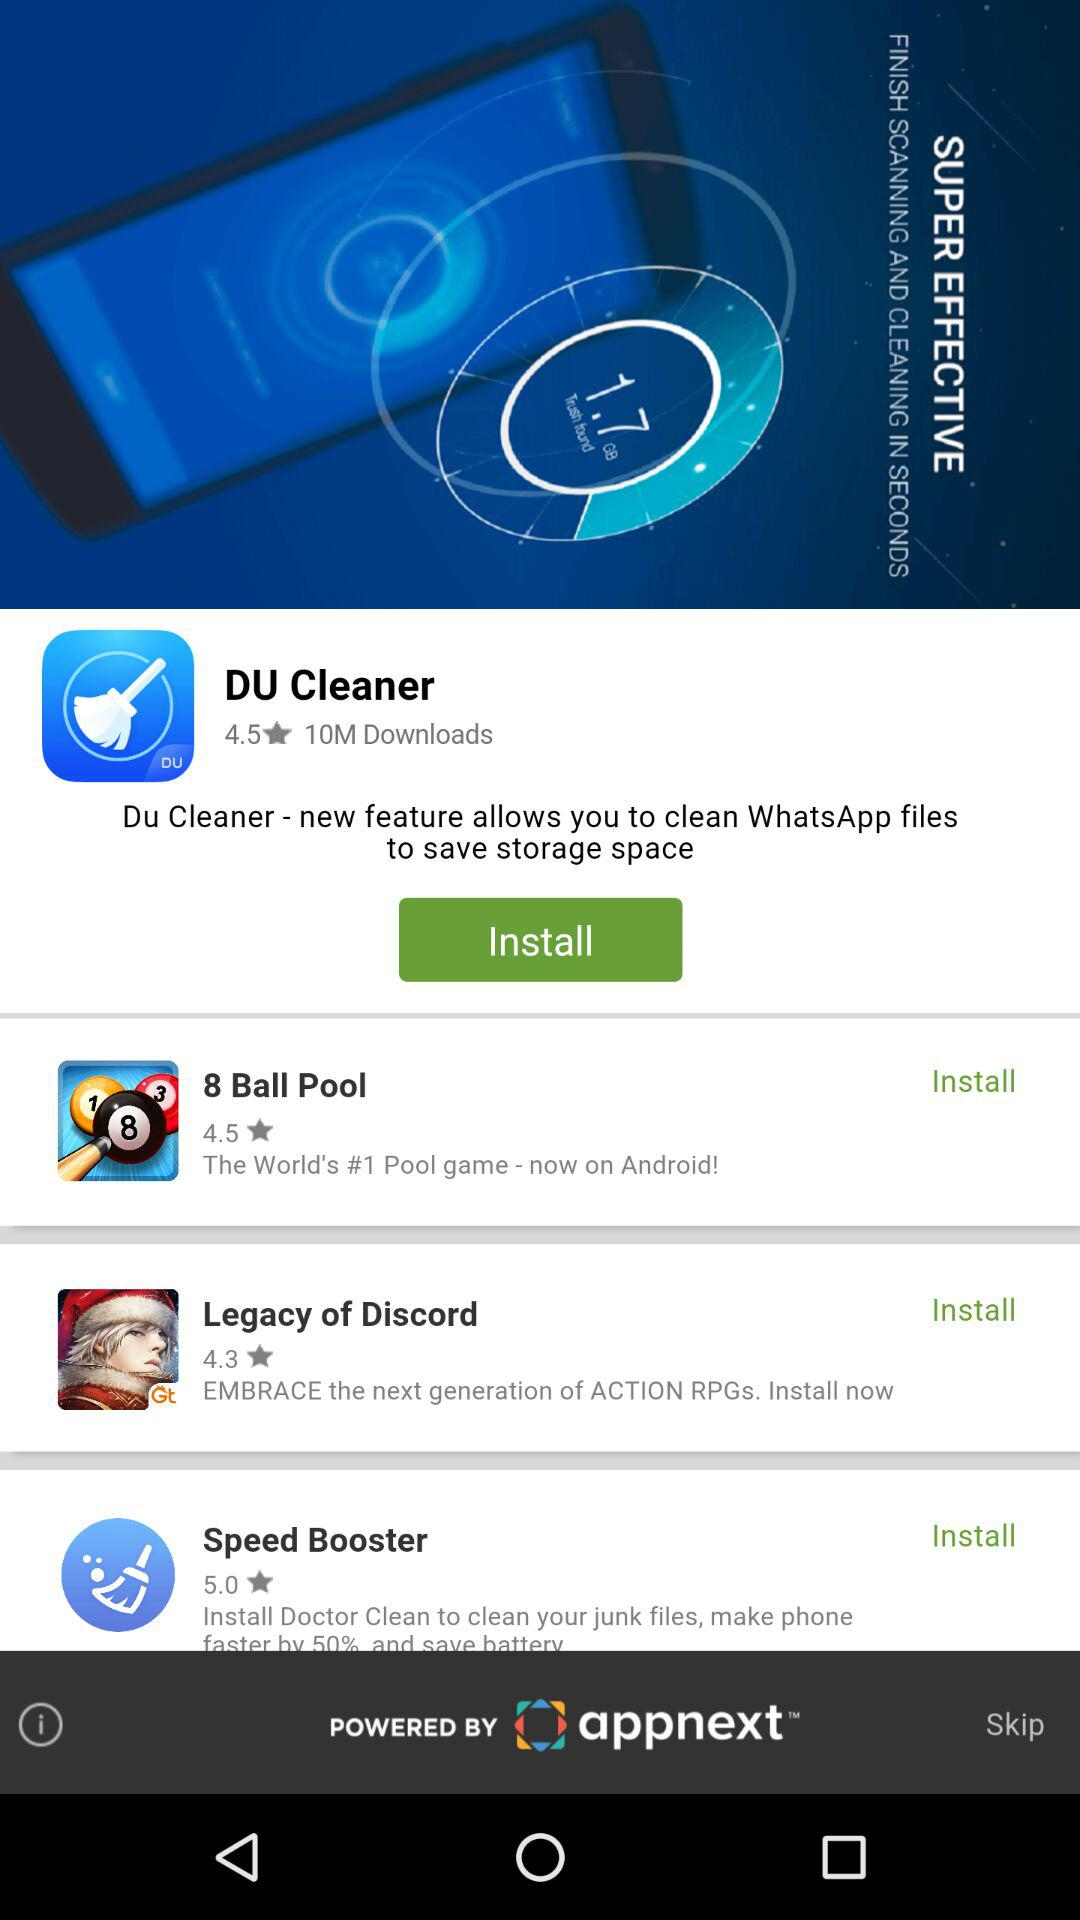How many DU cleaner apps have been downloaded? There are 10 million DU cleaner apps downloaded. 